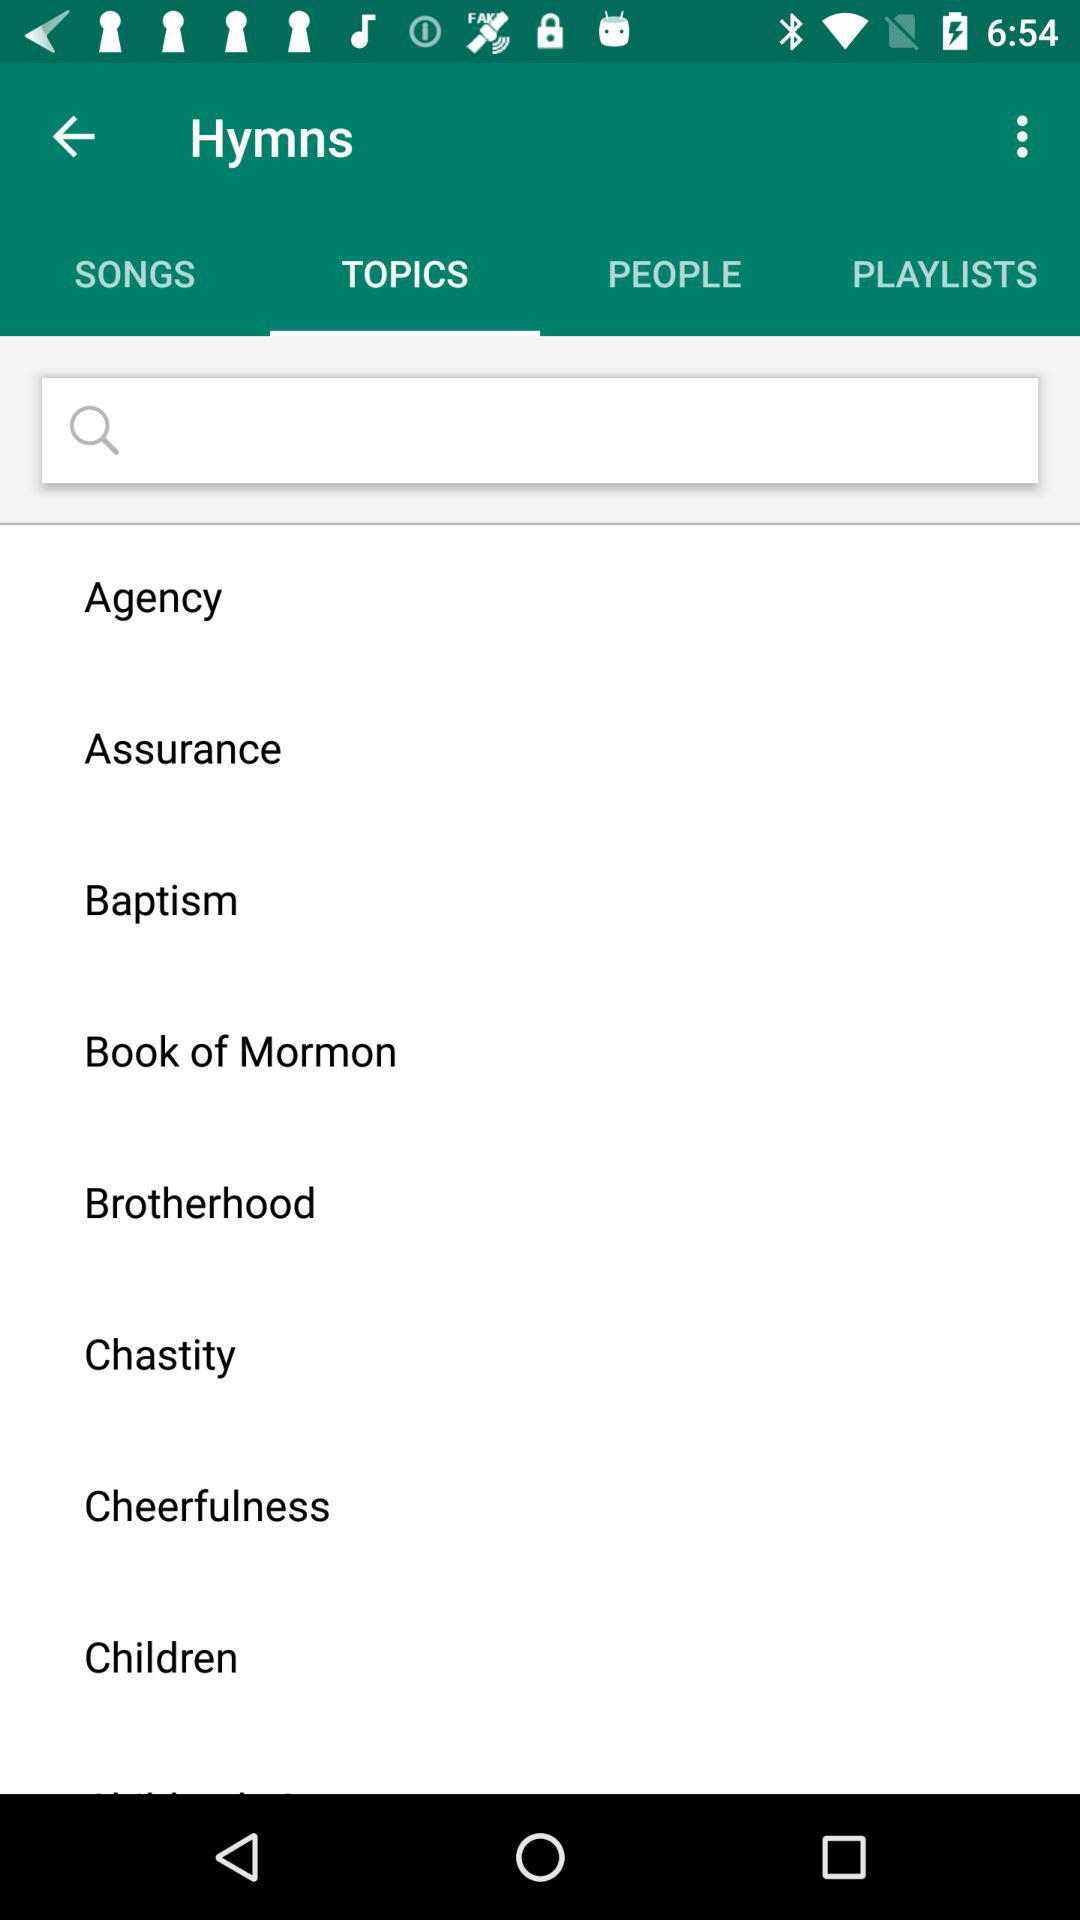Which tab is selected? The selected tab is "TOPICS". 